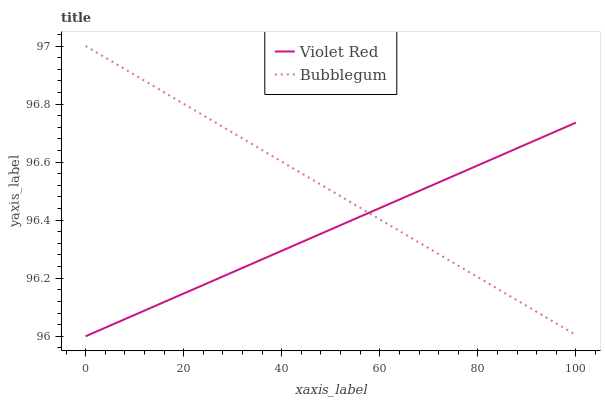Does Bubblegum have the minimum area under the curve?
Answer yes or no. No. Does Bubblegum have the lowest value?
Answer yes or no. No. 